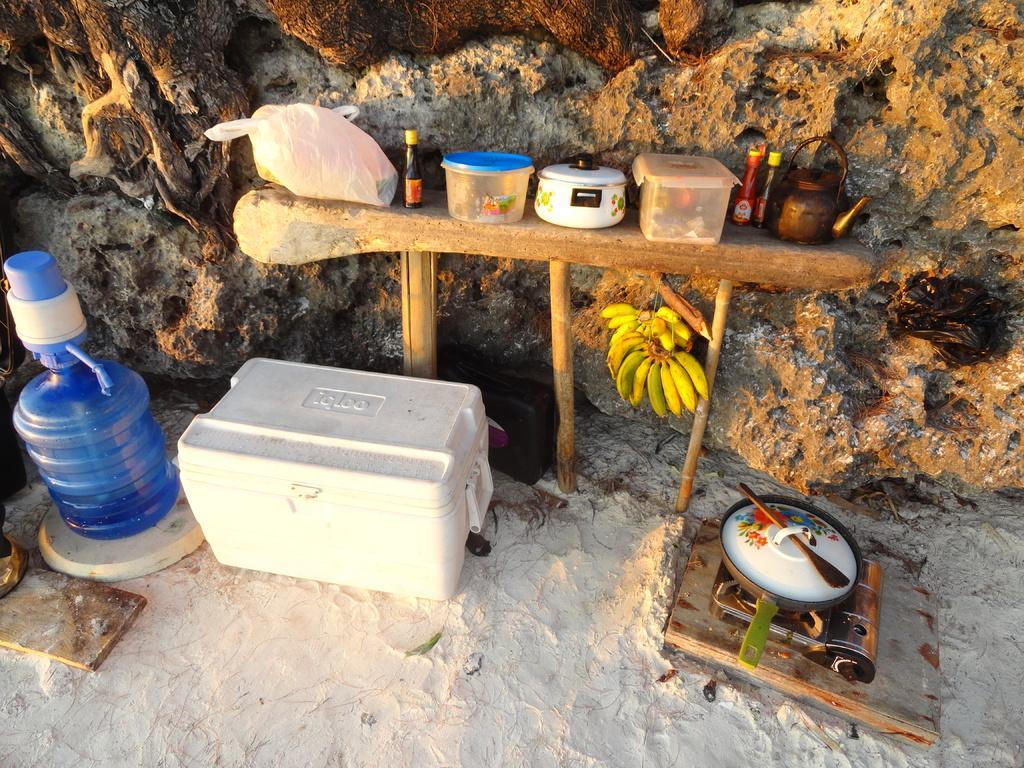Can you describe this image briefly? In this image, In the middle there is a table which i s in yellow color on that table there are boxes and there is a carry bag which is in white color and there are some bottles on the table, In the left side there is a white color box kept on the ground and there is a blue color bottle, In the right side there is a brown color table on that table there is a white color object, In the background there is a brown color wall. 